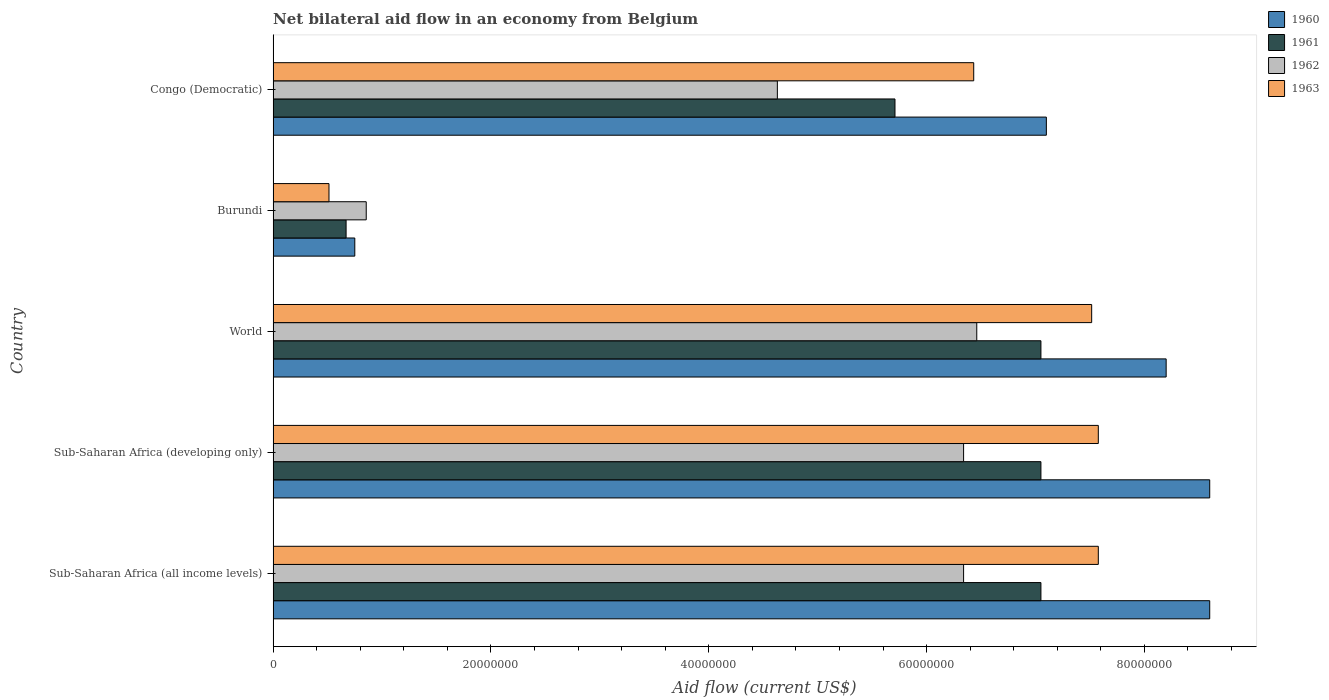How many groups of bars are there?
Your answer should be compact. 5. Are the number of bars per tick equal to the number of legend labels?
Offer a terse response. Yes. Are the number of bars on each tick of the Y-axis equal?
Your response must be concise. Yes. How many bars are there on the 2nd tick from the top?
Give a very brief answer. 4. How many bars are there on the 1st tick from the bottom?
Your answer should be very brief. 4. What is the label of the 5th group of bars from the top?
Offer a terse response. Sub-Saharan Africa (all income levels). What is the net bilateral aid flow in 1960 in Sub-Saharan Africa (all income levels)?
Your answer should be very brief. 8.60e+07. Across all countries, what is the maximum net bilateral aid flow in 1961?
Provide a succinct answer. 7.05e+07. Across all countries, what is the minimum net bilateral aid flow in 1963?
Keep it short and to the point. 5.13e+06. In which country was the net bilateral aid flow in 1962 maximum?
Provide a succinct answer. World. In which country was the net bilateral aid flow in 1963 minimum?
Provide a succinct answer. Burundi. What is the total net bilateral aid flow in 1963 in the graph?
Your answer should be compact. 2.96e+08. What is the difference between the net bilateral aid flow in 1963 in Burundi and that in Sub-Saharan Africa (developing only)?
Provide a short and direct response. -7.06e+07. What is the difference between the net bilateral aid flow in 1963 in Sub-Saharan Africa (developing only) and the net bilateral aid flow in 1961 in World?
Your answer should be compact. 5.27e+06. What is the average net bilateral aid flow in 1960 per country?
Make the answer very short. 6.65e+07. What is the difference between the net bilateral aid flow in 1962 and net bilateral aid flow in 1960 in Burundi?
Your answer should be very brief. 1.05e+06. In how many countries, is the net bilateral aid flow in 1960 greater than 4000000 US$?
Your answer should be very brief. 5. What is the ratio of the net bilateral aid flow in 1961 in Burundi to that in World?
Your answer should be compact. 0.1. Is the net bilateral aid flow in 1962 in Burundi less than that in Congo (Democratic)?
Keep it short and to the point. Yes. What is the difference between the highest and the second highest net bilateral aid flow in 1961?
Your answer should be compact. 0. What is the difference between the highest and the lowest net bilateral aid flow in 1960?
Your answer should be very brief. 7.85e+07. In how many countries, is the net bilateral aid flow in 1962 greater than the average net bilateral aid flow in 1962 taken over all countries?
Your answer should be very brief. 3. Is it the case that in every country, the sum of the net bilateral aid flow in 1963 and net bilateral aid flow in 1960 is greater than the sum of net bilateral aid flow in 1962 and net bilateral aid flow in 1961?
Your answer should be very brief. No. How many bars are there?
Offer a terse response. 20. Does the graph contain any zero values?
Your response must be concise. No. How many legend labels are there?
Provide a succinct answer. 4. What is the title of the graph?
Ensure brevity in your answer.  Net bilateral aid flow in an economy from Belgium. Does "2007" appear as one of the legend labels in the graph?
Your response must be concise. No. What is the label or title of the X-axis?
Offer a very short reply. Aid flow (current US$). What is the label or title of the Y-axis?
Offer a terse response. Country. What is the Aid flow (current US$) in 1960 in Sub-Saharan Africa (all income levels)?
Offer a terse response. 8.60e+07. What is the Aid flow (current US$) of 1961 in Sub-Saharan Africa (all income levels)?
Keep it short and to the point. 7.05e+07. What is the Aid flow (current US$) in 1962 in Sub-Saharan Africa (all income levels)?
Offer a terse response. 6.34e+07. What is the Aid flow (current US$) in 1963 in Sub-Saharan Africa (all income levels)?
Your answer should be compact. 7.58e+07. What is the Aid flow (current US$) in 1960 in Sub-Saharan Africa (developing only)?
Give a very brief answer. 8.60e+07. What is the Aid flow (current US$) in 1961 in Sub-Saharan Africa (developing only)?
Keep it short and to the point. 7.05e+07. What is the Aid flow (current US$) of 1962 in Sub-Saharan Africa (developing only)?
Provide a succinct answer. 6.34e+07. What is the Aid flow (current US$) of 1963 in Sub-Saharan Africa (developing only)?
Your response must be concise. 7.58e+07. What is the Aid flow (current US$) of 1960 in World?
Give a very brief answer. 8.20e+07. What is the Aid flow (current US$) of 1961 in World?
Make the answer very short. 7.05e+07. What is the Aid flow (current US$) of 1962 in World?
Ensure brevity in your answer.  6.46e+07. What is the Aid flow (current US$) of 1963 in World?
Your response must be concise. 7.52e+07. What is the Aid flow (current US$) of 1960 in Burundi?
Offer a terse response. 7.50e+06. What is the Aid flow (current US$) in 1961 in Burundi?
Your response must be concise. 6.70e+06. What is the Aid flow (current US$) in 1962 in Burundi?
Your response must be concise. 8.55e+06. What is the Aid flow (current US$) in 1963 in Burundi?
Make the answer very short. 5.13e+06. What is the Aid flow (current US$) in 1960 in Congo (Democratic)?
Offer a terse response. 7.10e+07. What is the Aid flow (current US$) in 1961 in Congo (Democratic)?
Keep it short and to the point. 5.71e+07. What is the Aid flow (current US$) in 1962 in Congo (Democratic)?
Ensure brevity in your answer.  4.63e+07. What is the Aid flow (current US$) in 1963 in Congo (Democratic)?
Give a very brief answer. 6.43e+07. Across all countries, what is the maximum Aid flow (current US$) of 1960?
Your answer should be compact. 8.60e+07. Across all countries, what is the maximum Aid flow (current US$) in 1961?
Your response must be concise. 7.05e+07. Across all countries, what is the maximum Aid flow (current US$) in 1962?
Give a very brief answer. 6.46e+07. Across all countries, what is the maximum Aid flow (current US$) of 1963?
Your answer should be very brief. 7.58e+07. Across all countries, what is the minimum Aid flow (current US$) of 1960?
Offer a very short reply. 7.50e+06. Across all countries, what is the minimum Aid flow (current US$) in 1961?
Your response must be concise. 6.70e+06. Across all countries, what is the minimum Aid flow (current US$) of 1962?
Provide a short and direct response. 8.55e+06. Across all countries, what is the minimum Aid flow (current US$) in 1963?
Provide a succinct answer. 5.13e+06. What is the total Aid flow (current US$) in 1960 in the graph?
Offer a very short reply. 3.32e+08. What is the total Aid flow (current US$) of 1961 in the graph?
Ensure brevity in your answer.  2.75e+08. What is the total Aid flow (current US$) of 1962 in the graph?
Your response must be concise. 2.46e+08. What is the total Aid flow (current US$) of 1963 in the graph?
Provide a succinct answer. 2.96e+08. What is the difference between the Aid flow (current US$) of 1961 in Sub-Saharan Africa (all income levels) and that in Sub-Saharan Africa (developing only)?
Keep it short and to the point. 0. What is the difference between the Aid flow (current US$) in 1963 in Sub-Saharan Africa (all income levels) and that in Sub-Saharan Africa (developing only)?
Your answer should be compact. 0. What is the difference between the Aid flow (current US$) in 1962 in Sub-Saharan Africa (all income levels) and that in World?
Keep it short and to the point. -1.21e+06. What is the difference between the Aid flow (current US$) in 1960 in Sub-Saharan Africa (all income levels) and that in Burundi?
Give a very brief answer. 7.85e+07. What is the difference between the Aid flow (current US$) in 1961 in Sub-Saharan Africa (all income levels) and that in Burundi?
Offer a terse response. 6.38e+07. What is the difference between the Aid flow (current US$) in 1962 in Sub-Saharan Africa (all income levels) and that in Burundi?
Provide a short and direct response. 5.48e+07. What is the difference between the Aid flow (current US$) in 1963 in Sub-Saharan Africa (all income levels) and that in Burundi?
Your answer should be compact. 7.06e+07. What is the difference between the Aid flow (current US$) in 1960 in Sub-Saharan Africa (all income levels) and that in Congo (Democratic)?
Your response must be concise. 1.50e+07. What is the difference between the Aid flow (current US$) in 1961 in Sub-Saharan Africa (all income levels) and that in Congo (Democratic)?
Provide a succinct answer. 1.34e+07. What is the difference between the Aid flow (current US$) in 1962 in Sub-Saharan Africa (all income levels) and that in Congo (Democratic)?
Provide a succinct answer. 1.71e+07. What is the difference between the Aid flow (current US$) of 1963 in Sub-Saharan Africa (all income levels) and that in Congo (Democratic)?
Your answer should be very brief. 1.14e+07. What is the difference between the Aid flow (current US$) in 1962 in Sub-Saharan Africa (developing only) and that in World?
Your answer should be compact. -1.21e+06. What is the difference between the Aid flow (current US$) in 1963 in Sub-Saharan Africa (developing only) and that in World?
Your response must be concise. 6.10e+05. What is the difference between the Aid flow (current US$) in 1960 in Sub-Saharan Africa (developing only) and that in Burundi?
Your response must be concise. 7.85e+07. What is the difference between the Aid flow (current US$) of 1961 in Sub-Saharan Africa (developing only) and that in Burundi?
Keep it short and to the point. 6.38e+07. What is the difference between the Aid flow (current US$) of 1962 in Sub-Saharan Africa (developing only) and that in Burundi?
Offer a terse response. 5.48e+07. What is the difference between the Aid flow (current US$) of 1963 in Sub-Saharan Africa (developing only) and that in Burundi?
Offer a terse response. 7.06e+07. What is the difference between the Aid flow (current US$) of 1960 in Sub-Saharan Africa (developing only) and that in Congo (Democratic)?
Your response must be concise. 1.50e+07. What is the difference between the Aid flow (current US$) of 1961 in Sub-Saharan Africa (developing only) and that in Congo (Democratic)?
Provide a succinct answer. 1.34e+07. What is the difference between the Aid flow (current US$) in 1962 in Sub-Saharan Africa (developing only) and that in Congo (Democratic)?
Ensure brevity in your answer.  1.71e+07. What is the difference between the Aid flow (current US$) in 1963 in Sub-Saharan Africa (developing only) and that in Congo (Democratic)?
Provide a succinct answer. 1.14e+07. What is the difference between the Aid flow (current US$) in 1960 in World and that in Burundi?
Give a very brief answer. 7.45e+07. What is the difference between the Aid flow (current US$) of 1961 in World and that in Burundi?
Make the answer very short. 6.38e+07. What is the difference between the Aid flow (current US$) in 1962 in World and that in Burundi?
Your answer should be very brief. 5.61e+07. What is the difference between the Aid flow (current US$) in 1963 in World and that in Burundi?
Give a very brief answer. 7.00e+07. What is the difference between the Aid flow (current US$) of 1960 in World and that in Congo (Democratic)?
Provide a succinct answer. 1.10e+07. What is the difference between the Aid flow (current US$) in 1961 in World and that in Congo (Democratic)?
Offer a terse response. 1.34e+07. What is the difference between the Aid flow (current US$) in 1962 in World and that in Congo (Democratic)?
Ensure brevity in your answer.  1.83e+07. What is the difference between the Aid flow (current US$) of 1963 in World and that in Congo (Democratic)?
Your answer should be compact. 1.08e+07. What is the difference between the Aid flow (current US$) in 1960 in Burundi and that in Congo (Democratic)?
Give a very brief answer. -6.35e+07. What is the difference between the Aid flow (current US$) of 1961 in Burundi and that in Congo (Democratic)?
Make the answer very short. -5.04e+07. What is the difference between the Aid flow (current US$) in 1962 in Burundi and that in Congo (Democratic)?
Ensure brevity in your answer.  -3.78e+07. What is the difference between the Aid flow (current US$) in 1963 in Burundi and that in Congo (Democratic)?
Offer a very short reply. -5.92e+07. What is the difference between the Aid flow (current US$) of 1960 in Sub-Saharan Africa (all income levels) and the Aid flow (current US$) of 1961 in Sub-Saharan Africa (developing only)?
Provide a succinct answer. 1.55e+07. What is the difference between the Aid flow (current US$) in 1960 in Sub-Saharan Africa (all income levels) and the Aid flow (current US$) in 1962 in Sub-Saharan Africa (developing only)?
Provide a short and direct response. 2.26e+07. What is the difference between the Aid flow (current US$) in 1960 in Sub-Saharan Africa (all income levels) and the Aid flow (current US$) in 1963 in Sub-Saharan Africa (developing only)?
Ensure brevity in your answer.  1.02e+07. What is the difference between the Aid flow (current US$) of 1961 in Sub-Saharan Africa (all income levels) and the Aid flow (current US$) of 1962 in Sub-Saharan Africa (developing only)?
Offer a very short reply. 7.10e+06. What is the difference between the Aid flow (current US$) of 1961 in Sub-Saharan Africa (all income levels) and the Aid flow (current US$) of 1963 in Sub-Saharan Africa (developing only)?
Provide a succinct answer. -5.27e+06. What is the difference between the Aid flow (current US$) in 1962 in Sub-Saharan Africa (all income levels) and the Aid flow (current US$) in 1963 in Sub-Saharan Africa (developing only)?
Offer a very short reply. -1.24e+07. What is the difference between the Aid flow (current US$) in 1960 in Sub-Saharan Africa (all income levels) and the Aid flow (current US$) in 1961 in World?
Ensure brevity in your answer.  1.55e+07. What is the difference between the Aid flow (current US$) in 1960 in Sub-Saharan Africa (all income levels) and the Aid flow (current US$) in 1962 in World?
Your answer should be compact. 2.14e+07. What is the difference between the Aid flow (current US$) in 1960 in Sub-Saharan Africa (all income levels) and the Aid flow (current US$) in 1963 in World?
Provide a short and direct response. 1.08e+07. What is the difference between the Aid flow (current US$) of 1961 in Sub-Saharan Africa (all income levels) and the Aid flow (current US$) of 1962 in World?
Your response must be concise. 5.89e+06. What is the difference between the Aid flow (current US$) in 1961 in Sub-Saharan Africa (all income levels) and the Aid flow (current US$) in 1963 in World?
Offer a very short reply. -4.66e+06. What is the difference between the Aid flow (current US$) of 1962 in Sub-Saharan Africa (all income levels) and the Aid flow (current US$) of 1963 in World?
Provide a succinct answer. -1.18e+07. What is the difference between the Aid flow (current US$) of 1960 in Sub-Saharan Africa (all income levels) and the Aid flow (current US$) of 1961 in Burundi?
Your response must be concise. 7.93e+07. What is the difference between the Aid flow (current US$) in 1960 in Sub-Saharan Africa (all income levels) and the Aid flow (current US$) in 1962 in Burundi?
Ensure brevity in your answer.  7.74e+07. What is the difference between the Aid flow (current US$) of 1960 in Sub-Saharan Africa (all income levels) and the Aid flow (current US$) of 1963 in Burundi?
Make the answer very short. 8.09e+07. What is the difference between the Aid flow (current US$) of 1961 in Sub-Saharan Africa (all income levels) and the Aid flow (current US$) of 1962 in Burundi?
Provide a succinct answer. 6.20e+07. What is the difference between the Aid flow (current US$) of 1961 in Sub-Saharan Africa (all income levels) and the Aid flow (current US$) of 1963 in Burundi?
Your answer should be compact. 6.54e+07. What is the difference between the Aid flow (current US$) in 1962 in Sub-Saharan Africa (all income levels) and the Aid flow (current US$) in 1963 in Burundi?
Provide a succinct answer. 5.83e+07. What is the difference between the Aid flow (current US$) of 1960 in Sub-Saharan Africa (all income levels) and the Aid flow (current US$) of 1961 in Congo (Democratic)?
Give a very brief answer. 2.89e+07. What is the difference between the Aid flow (current US$) of 1960 in Sub-Saharan Africa (all income levels) and the Aid flow (current US$) of 1962 in Congo (Democratic)?
Make the answer very short. 3.97e+07. What is the difference between the Aid flow (current US$) of 1960 in Sub-Saharan Africa (all income levels) and the Aid flow (current US$) of 1963 in Congo (Democratic)?
Provide a short and direct response. 2.17e+07. What is the difference between the Aid flow (current US$) in 1961 in Sub-Saharan Africa (all income levels) and the Aid flow (current US$) in 1962 in Congo (Democratic)?
Give a very brief answer. 2.42e+07. What is the difference between the Aid flow (current US$) in 1961 in Sub-Saharan Africa (all income levels) and the Aid flow (current US$) in 1963 in Congo (Democratic)?
Provide a short and direct response. 6.17e+06. What is the difference between the Aid flow (current US$) of 1962 in Sub-Saharan Africa (all income levels) and the Aid flow (current US$) of 1963 in Congo (Democratic)?
Your answer should be compact. -9.30e+05. What is the difference between the Aid flow (current US$) in 1960 in Sub-Saharan Africa (developing only) and the Aid flow (current US$) in 1961 in World?
Offer a very short reply. 1.55e+07. What is the difference between the Aid flow (current US$) in 1960 in Sub-Saharan Africa (developing only) and the Aid flow (current US$) in 1962 in World?
Your response must be concise. 2.14e+07. What is the difference between the Aid flow (current US$) of 1960 in Sub-Saharan Africa (developing only) and the Aid flow (current US$) of 1963 in World?
Ensure brevity in your answer.  1.08e+07. What is the difference between the Aid flow (current US$) in 1961 in Sub-Saharan Africa (developing only) and the Aid flow (current US$) in 1962 in World?
Your answer should be compact. 5.89e+06. What is the difference between the Aid flow (current US$) of 1961 in Sub-Saharan Africa (developing only) and the Aid flow (current US$) of 1963 in World?
Give a very brief answer. -4.66e+06. What is the difference between the Aid flow (current US$) in 1962 in Sub-Saharan Africa (developing only) and the Aid flow (current US$) in 1963 in World?
Offer a terse response. -1.18e+07. What is the difference between the Aid flow (current US$) of 1960 in Sub-Saharan Africa (developing only) and the Aid flow (current US$) of 1961 in Burundi?
Provide a short and direct response. 7.93e+07. What is the difference between the Aid flow (current US$) in 1960 in Sub-Saharan Africa (developing only) and the Aid flow (current US$) in 1962 in Burundi?
Keep it short and to the point. 7.74e+07. What is the difference between the Aid flow (current US$) in 1960 in Sub-Saharan Africa (developing only) and the Aid flow (current US$) in 1963 in Burundi?
Offer a terse response. 8.09e+07. What is the difference between the Aid flow (current US$) of 1961 in Sub-Saharan Africa (developing only) and the Aid flow (current US$) of 1962 in Burundi?
Your answer should be very brief. 6.20e+07. What is the difference between the Aid flow (current US$) in 1961 in Sub-Saharan Africa (developing only) and the Aid flow (current US$) in 1963 in Burundi?
Give a very brief answer. 6.54e+07. What is the difference between the Aid flow (current US$) of 1962 in Sub-Saharan Africa (developing only) and the Aid flow (current US$) of 1963 in Burundi?
Make the answer very short. 5.83e+07. What is the difference between the Aid flow (current US$) of 1960 in Sub-Saharan Africa (developing only) and the Aid flow (current US$) of 1961 in Congo (Democratic)?
Offer a very short reply. 2.89e+07. What is the difference between the Aid flow (current US$) of 1960 in Sub-Saharan Africa (developing only) and the Aid flow (current US$) of 1962 in Congo (Democratic)?
Your answer should be compact. 3.97e+07. What is the difference between the Aid flow (current US$) of 1960 in Sub-Saharan Africa (developing only) and the Aid flow (current US$) of 1963 in Congo (Democratic)?
Your response must be concise. 2.17e+07. What is the difference between the Aid flow (current US$) in 1961 in Sub-Saharan Africa (developing only) and the Aid flow (current US$) in 1962 in Congo (Democratic)?
Offer a very short reply. 2.42e+07. What is the difference between the Aid flow (current US$) of 1961 in Sub-Saharan Africa (developing only) and the Aid flow (current US$) of 1963 in Congo (Democratic)?
Provide a succinct answer. 6.17e+06. What is the difference between the Aid flow (current US$) of 1962 in Sub-Saharan Africa (developing only) and the Aid flow (current US$) of 1963 in Congo (Democratic)?
Make the answer very short. -9.30e+05. What is the difference between the Aid flow (current US$) of 1960 in World and the Aid flow (current US$) of 1961 in Burundi?
Provide a short and direct response. 7.53e+07. What is the difference between the Aid flow (current US$) in 1960 in World and the Aid flow (current US$) in 1962 in Burundi?
Your answer should be very brief. 7.34e+07. What is the difference between the Aid flow (current US$) of 1960 in World and the Aid flow (current US$) of 1963 in Burundi?
Offer a terse response. 7.69e+07. What is the difference between the Aid flow (current US$) in 1961 in World and the Aid flow (current US$) in 1962 in Burundi?
Your answer should be compact. 6.20e+07. What is the difference between the Aid flow (current US$) in 1961 in World and the Aid flow (current US$) in 1963 in Burundi?
Your answer should be very brief. 6.54e+07. What is the difference between the Aid flow (current US$) of 1962 in World and the Aid flow (current US$) of 1963 in Burundi?
Keep it short and to the point. 5.95e+07. What is the difference between the Aid flow (current US$) in 1960 in World and the Aid flow (current US$) in 1961 in Congo (Democratic)?
Provide a short and direct response. 2.49e+07. What is the difference between the Aid flow (current US$) of 1960 in World and the Aid flow (current US$) of 1962 in Congo (Democratic)?
Keep it short and to the point. 3.57e+07. What is the difference between the Aid flow (current US$) of 1960 in World and the Aid flow (current US$) of 1963 in Congo (Democratic)?
Provide a short and direct response. 1.77e+07. What is the difference between the Aid flow (current US$) of 1961 in World and the Aid flow (current US$) of 1962 in Congo (Democratic)?
Provide a short and direct response. 2.42e+07. What is the difference between the Aid flow (current US$) of 1961 in World and the Aid flow (current US$) of 1963 in Congo (Democratic)?
Offer a terse response. 6.17e+06. What is the difference between the Aid flow (current US$) of 1960 in Burundi and the Aid flow (current US$) of 1961 in Congo (Democratic)?
Offer a terse response. -4.96e+07. What is the difference between the Aid flow (current US$) in 1960 in Burundi and the Aid flow (current US$) in 1962 in Congo (Democratic)?
Keep it short and to the point. -3.88e+07. What is the difference between the Aid flow (current US$) in 1960 in Burundi and the Aid flow (current US$) in 1963 in Congo (Democratic)?
Give a very brief answer. -5.68e+07. What is the difference between the Aid flow (current US$) in 1961 in Burundi and the Aid flow (current US$) in 1962 in Congo (Democratic)?
Offer a very short reply. -3.96e+07. What is the difference between the Aid flow (current US$) in 1961 in Burundi and the Aid flow (current US$) in 1963 in Congo (Democratic)?
Make the answer very short. -5.76e+07. What is the difference between the Aid flow (current US$) of 1962 in Burundi and the Aid flow (current US$) of 1963 in Congo (Democratic)?
Make the answer very short. -5.58e+07. What is the average Aid flow (current US$) of 1960 per country?
Your response must be concise. 6.65e+07. What is the average Aid flow (current US$) in 1961 per country?
Provide a succinct answer. 5.51e+07. What is the average Aid flow (current US$) in 1962 per country?
Offer a very short reply. 4.93e+07. What is the average Aid flow (current US$) in 1963 per country?
Keep it short and to the point. 5.92e+07. What is the difference between the Aid flow (current US$) of 1960 and Aid flow (current US$) of 1961 in Sub-Saharan Africa (all income levels)?
Offer a very short reply. 1.55e+07. What is the difference between the Aid flow (current US$) of 1960 and Aid flow (current US$) of 1962 in Sub-Saharan Africa (all income levels)?
Offer a very short reply. 2.26e+07. What is the difference between the Aid flow (current US$) in 1960 and Aid flow (current US$) in 1963 in Sub-Saharan Africa (all income levels)?
Ensure brevity in your answer.  1.02e+07. What is the difference between the Aid flow (current US$) in 1961 and Aid flow (current US$) in 1962 in Sub-Saharan Africa (all income levels)?
Offer a very short reply. 7.10e+06. What is the difference between the Aid flow (current US$) of 1961 and Aid flow (current US$) of 1963 in Sub-Saharan Africa (all income levels)?
Provide a succinct answer. -5.27e+06. What is the difference between the Aid flow (current US$) of 1962 and Aid flow (current US$) of 1963 in Sub-Saharan Africa (all income levels)?
Keep it short and to the point. -1.24e+07. What is the difference between the Aid flow (current US$) in 1960 and Aid flow (current US$) in 1961 in Sub-Saharan Africa (developing only)?
Your answer should be compact. 1.55e+07. What is the difference between the Aid flow (current US$) of 1960 and Aid flow (current US$) of 1962 in Sub-Saharan Africa (developing only)?
Provide a succinct answer. 2.26e+07. What is the difference between the Aid flow (current US$) of 1960 and Aid flow (current US$) of 1963 in Sub-Saharan Africa (developing only)?
Provide a succinct answer. 1.02e+07. What is the difference between the Aid flow (current US$) of 1961 and Aid flow (current US$) of 1962 in Sub-Saharan Africa (developing only)?
Your answer should be very brief. 7.10e+06. What is the difference between the Aid flow (current US$) of 1961 and Aid flow (current US$) of 1963 in Sub-Saharan Africa (developing only)?
Your answer should be very brief. -5.27e+06. What is the difference between the Aid flow (current US$) of 1962 and Aid flow (current US$) of 1963 in Sub-Saharan Africa (developing only)?
Your answer should be compact. -1.24e+07. What is the difference between the Aid flow (current US$) of 1960 and Aid flow (current US$) of 1961 in World?
Offer a very short reply. 1.15e+07. What is the difference between the Aid flow (current US$) of 1960 and Aid flow (current US$) of 1962 in World?
Make the answer very short. 1.74e+07. What is the difference between the Aid flow (current US$) of 1960 and Aid flow (current US$) of 1963 in World?
Keep it short and to the point. 6.84e+06. What is the difference between the Aid flow (current US$) in 1961 and Aid flow (current US$) in 1962 in World?
Offer a terse response. 5.89e+06. What is the difference between the Aid flow (current US$) of 1961 and Aid flow (current US$) of 1963 in World?
Provide a succinct answer. -4.66e+06. What is the difference between the Aid flow (current US$) in 1962 and Aid flow (current US$) in 1963 in World?
Ensure brevity in your answer.  -1.06e+07. What is the difference between the Aid flow (current US$) of 1960 and Aid flow (current US$) of 1961 in Burundi?
Your answer should be compact. 8.00e+05. What is the difference between the Aid flow (current US$) in 1960 and Aid flow (current US$) in 1962 in Burundi?
Provide a short and direct response. -1.05e+06. What is the difference between the Aid flow (current US$) of 1960 and Aid flow (current US$) of 1963 in Burundi?
Offer a terse response. 2.37e+06. What is the difference between the Aid flow (current US$) in 1961 and Aid flow (current US$) in 1962 in Burundi?
Give a very brief answer. -1.85e+06. What is the difference between the Aid flow (current US$) in 1961 and Aid flow (current US$) in 1963 in Burundi?
Keep it short and to the point. 1.57e+06. What is the difference between the Aid flow (current US$) of 1962 and Aid flow (current US$) of 1963 in Burundi?
Ensure brevity in your answer.  3.42e+06. What is the difference between the Aid flow (current US$) of 1960 and Aid flow (current US$) of 1961 in Congo (Democratic)?
Provide a succinct answer. 1.39e+07. What is the difference between the Aid flow (current US$) of 1960 and Aid flow (current US$) of 1962 in Congo (Democratic)?
Provide a short and direct response. 2.47e+07. What is the difference between the Aid flow (current US$) in 1960 and Aid flow (current US$) in 1963 in Congo (Democratic)?
Provide a succinct answer. 6.67e+06. What is the difference between the Aid flow (current US$) in 1961 and Aid flow (current US$) in 1962 in Congo (Democratic)?
Your answer should be compact. 1.08e+07. What is the difference between the Aid flow (current US$) in 1961 and Aid flow (current US$) in 1963 in Congo (Democratic)?
Offer a very short reply. -7.23e+06. What is the difference between the Aid flow (current US$) of 1962 and Aid flow (current US$) of 1963 in Congo (Democratic)?
Your response must be concise. -1.80e+07. What is the ratio of the Aid flow (current US$) in 1960 in Sub-Saharan Africa (all income levels) to that in Sub-Saharan Africa (developing only)?
Your answer should be very brief. 1. What is the ratio of the Aid flow (current US$) in 1961 in Sub-Saharan Africa (all income levels) to that in Sub-Saharan Africa (developing only)?
Provide a short and direct response. 1. What is the ratio of the Aid flow (current US$) in 1960 in Sub-Saharan Africa (all income levels) to that in World?
Give a very brief answer. 1.05. What is the ratio of the Aid flow (current US$) of 1961 in Sub-Saharan Africa (all income levels) to that in World?
Offer a terse response. 1. What is the ratio of the Aid flow (current US$) of 1962 in Sub-Saharan Africa (all income levels) to that in World?
Offer a very short reply. 0.98. What is the ratio of the Aid flow (current US$) of 1963 in Sub-Saharan Africa (all income levels) to that in World?
Make the answer very short. 1.01. What is the ratio of the Aid flow (current US$) in 1960 in Sub-Saharan Africa (all income levels) to that in Burundi?
Your answer should be very brief. 11.47. What is the ratio of the Aid flow (current US$) of 1961 in Sub-Saharan Africa (all income levels) to that in Burundi?
Ensure brevity in your answer.  10.52. What is the ratio of the Aid flow (current US$) in 1962 in Sub-Saharan Africa (all income levels) to that in Burundi?
Your answer should be compact. 7.42. What is the ratio of the Aid flow (current US$) in 1963 in Sub-Saharan Africa (all income levels) to that in Burundi?
Your answer should be very brief. 14.77. What is the ratio of the Aid flow (current US$) in 1960 in Sub-Saharan Africa (all income levels) to that in Congo (Democratic)?
Provide a short and direct response. 1.21. What is the ratio of the Aid flow (current US$) in 1961 in Sub-Saharan Africa (all income levels) to that in Congo (Democratic)?
Your answer should be compact. 1.23. What is the ratio of the Aid flow (current US$) in 1962 in Sub-Saharan Africa (all income levels) to that in Congo (Democratic)?
Make the answer very short. 1.37. What is the ratio of the Aid flow (current US$) in 1963 in Sub-Saharan Africa (all income levels) to that in Congo (Democratic)?
Give a very brief answer. 1.18. What is the ratio of the Aid flow (current US$) of 1960 in Sub-Saharan Africa (developing only) to that in World?
Offer a very short reply. 1.05. What is the ratio of the Aid flow (current US$) in 1962 in Sub-Saharan Africa (developing only) to that in World?
Give a very brief answer. 0.98. What is the ratio of the Aid flow (current US$) of 1963 in Sub-Saharan Africa (developing only) to that in World?
Your response must be concise. 1.01. What is the ratio of the Aid flow (current US$) in 1960 in Sub-Saharan Africa (developing only) to that in Burundi?
Offer a very short reply. 11.47. What is the ratio of the Aid flow (current US$) in 1961 in Sub-Saharan Africa (developing only) to that in Burundi?
Keep it short and to the point. 10.52. What is the ratio of the Aid flow (current US$) of 1962 in Sub-Saharan Africa (developing only) to that in Burundi?
Provide a short and direct response. 7.42. What is the ratio of the Aid flow (current US$) in 1963 in Sub-Saharan Africa (developing only) to that in Burundi?
Your response must be concise. 14.77. What is the ratio of the Aid flow (current US$) in 1960 in Sub-Saharan Africa (developing only) to that in Congo (Democratic)?
Make the answer very short. 1.21. What is the ratio of the Aid flow (current US$) in 1961 in Sub-Saharan Africa (developing only) to that in Congo (Democratic)?
Make the answer very short. 1.23. What is the ratio of the Aid flow (current US$) of 1962 in Sub-Saharan Africa (developing only) to that in Congo (Democratic)?
Provide a succinct answer. 1.37. What is the ratio of the Aid flow (current US$) of 1963 in Sub-Saharan Africa (developing only) to that in Congo (Democratic)?
Your answer should be very brief. 1.18. What is the ratio of the Aid flow (current US$) of 1960 in World to that in Burundi?
Your answer should be compact. 10.93. What is the ratio of the Aid flow (current US$) in 1961 in World to that in Burundi?
Your response must be concise. 10.52. What is the ratio of the Aid flow (current US$) in 1962 in World to that in Burundi?
Provide a short and direct response. 7.56. What is the ratio of the Aid flow (current US$) in 1963 in World to that in Burundi?
Your response must be concise. 14.65. What is the ratio of the Aid flow (current US$) of 1960 in World to that in Congo (Democratic)?
Ensure brevity in your answer.  1.15. What is the ratio of the Aid flow (current US$) of 1961 in World to that in Congo (Democratic)?
Your answer should be very brief. 1.23. What is the ratio of the Aid flow (current US$) of 1962 in World to that in Congo (Democratic)?
Your answer should be compact. 1.4. What is the ratio of the Aid flow (current US$) of 1963 in World to that in Congo (Democratic)?
Provide a short and direct response. 1.17. What is the ratio of the Aid flow (current US$) in 1960 in Burundi to that in Congo (Democratic)?
Make the answer very short. 0.11. What is the ratio of the Aid flow (current US$) of 1961 in Burundi to that in Congo (Democratic)?
Provide a succinct answer. 0.12. What is the ratio of the Aid flow (current US$) in 1962 in Burundi to that in Congo (Democratic)?
Your response must be concise. 0.18. What is the ratio of the Aid flow (current US$) in 1963 in Burundi to that in Congo (Democratic)?
Give a very brief answer. 0.08. What is the difference between the highest and the second highest Aid flow (current US$) in 1960?
Ensure brevity in your answer.  0. What is the difference between the highest and the second highest Aid flow (current US$) of 1961?
Provide a short and direct response. 0. What is the difference between the highest and the second highest Aid flow (current US$) of 1962?
Provide a succinct answer. 1.21e+06. What is the difference between the highest and the second highest Aid flow (current US$) of 1963?
Give a very brief answer. 0. What is the difference between the highest and the lowest Aid flow (current US$) of 1960?
Your answer should be very brief. 7.85e+07. What is the difference between the highest and the lowest Aid flow (current US$) of 1961?
Provide a short and direct response. 6.38e+07. What is the difference between the highest and the lowest Aid flow (current US$) of 1962?
Give a very brief answer. 5.61e+07. What is the difference between the highest and the lowest Aid flow (current US$) in 1963?
Make the answer very short. 7.06e+07. 